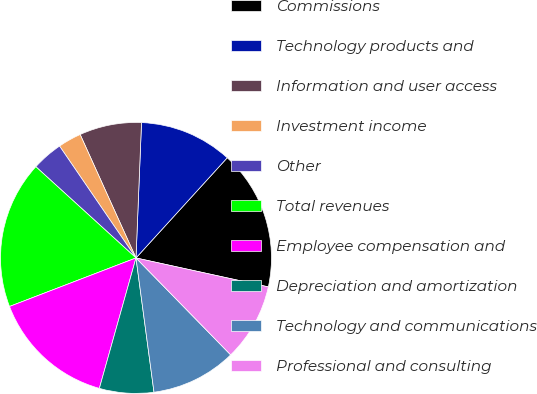Convert chart to OTSL. <chart><loc_0><loc_0><loc_500><loc_500><pie_chart><fcel>Commissions<fcel>Technology products and<fcel>Information and user access<fcel>Investment income<fcel>Other<fcel>Total revenues<fcel>Employee compensation and<fcel>Depreciation and amortization<fcel>Technology and communications<fcel>Professional and consulting<nl><fcel>16.67%<fcel>11.11%<fcel>7.41%<fcel>2.78%<fcel>3.7%<fcel>17.59%<fcel>14.81%<fcel>6.48%<fcel>10.19%<fcel>9.26%<nl></chart> 